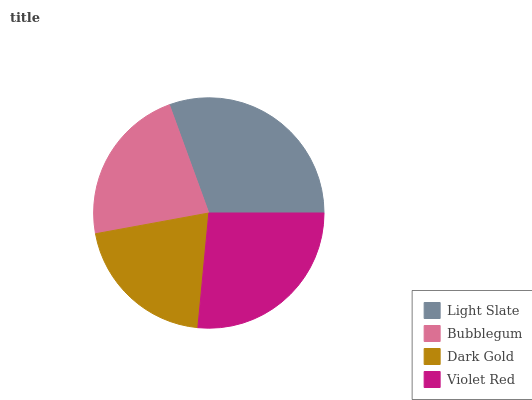Is Dark Gold the minimum?
Answer yes or no. Yes. Is Light Slate the maximum?
Answer yes or no. Yes. Is Bubblegum the minimum?
Answer yes or no. No. Is Bubblegum the maximum?
Answer yes or no. No. Is Light Slate greater than Bubblegum?
Answer yes or no. Yes. Is Bubblegum less than Light Slate?
Answer yes or no. Yes. Is Bubblegum greater than Light Slate?
Answer yes or no. No. Is Light Slate less than Bubblegum?
Answer yes or no. No. Is Violet Red the high median?
Answer yes or no. Yes. Is Bubblegum the low median?
Answer yes or no. Yes. Is Dark Gold the high median?
Answer yes or no. No. Is Violet Red the low median?
Answer yes or no. No. 